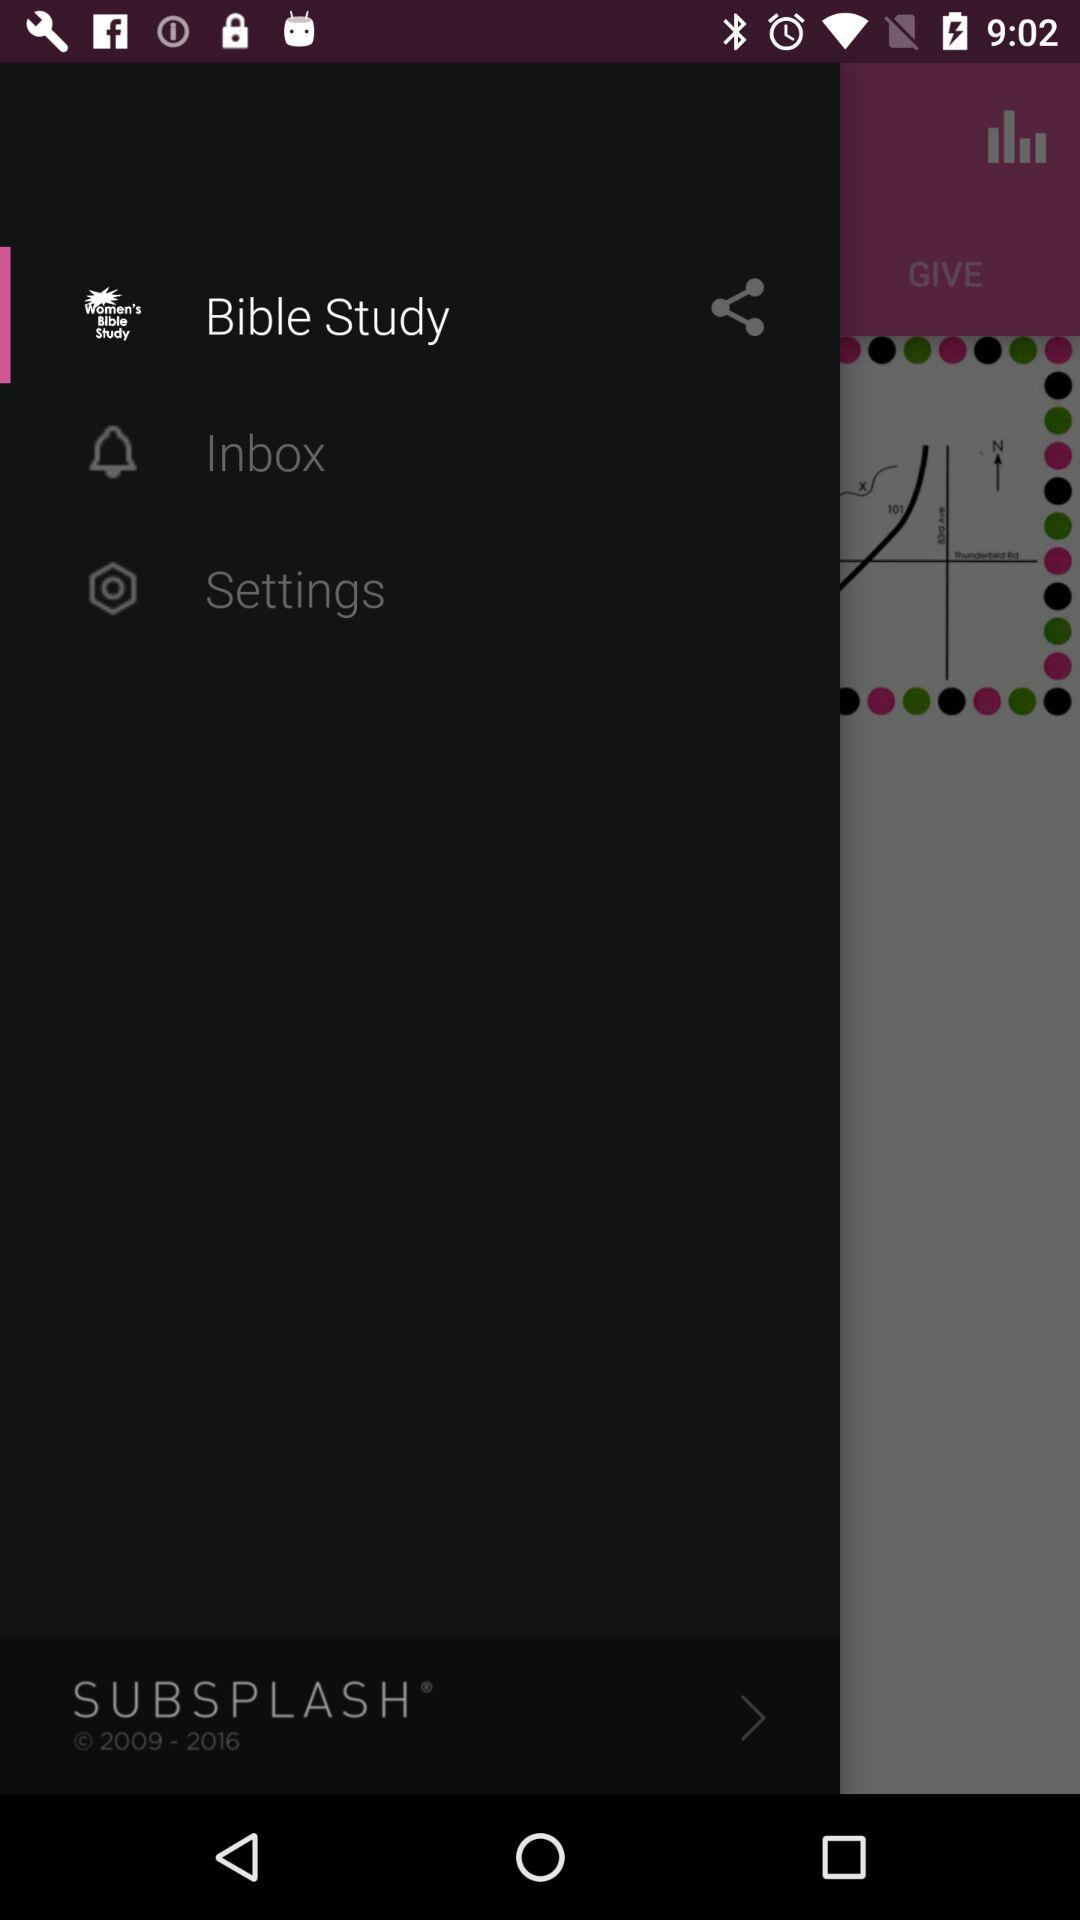What is the application name? The application name is "Bible Study". 